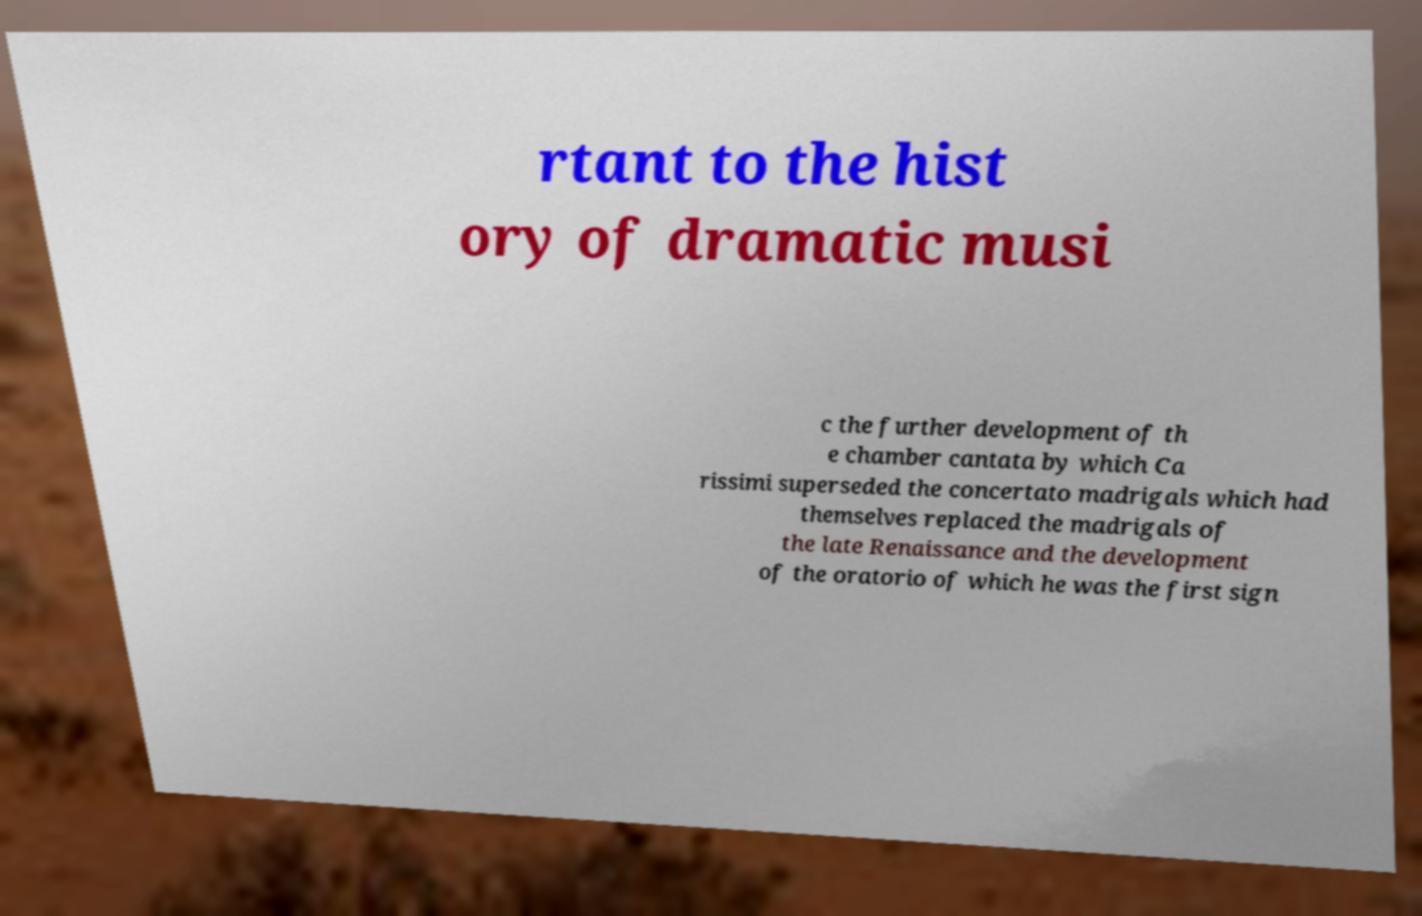Could you extract and type out the text from this image? rtant to the hist ory of dramatic musi c the further development of th e chamber cantata by which Ca rissimi superseded the concertato madrigals which had themselves replaced the madrigals of the late Renaissance and the development of the oratorio of which he was the first sign 